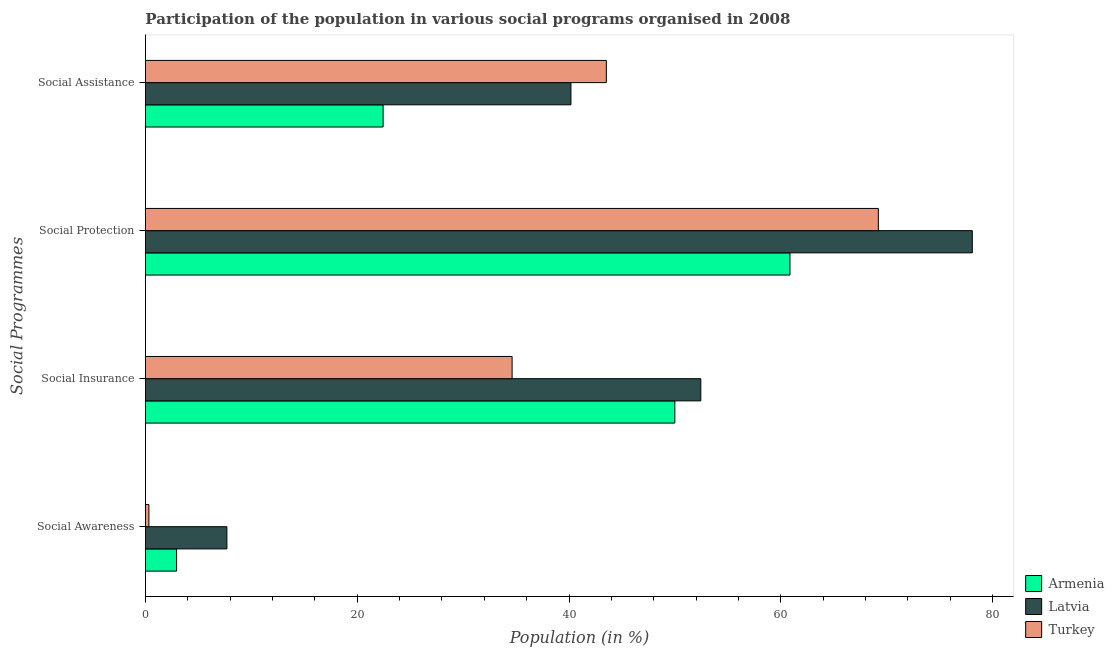How many different coloured bars are there?
Make the answer very short. 3. How many groups of bars are there?
Offer a very short reply. 4. Are the number of bars on each tick of the Y-axis equal?
Offer a terse response. Yes. How many bars are there on the 4th tick from the bottom?
Your answer should be very brief. 3. What is the label of the 4th group of bars from the top?
Provide a succinct answer. Social Awareness. What is the participation of population in social assistance programs in Armenia?
Make the answer very short. 22.44. Across all countries, what is the maximum participation of population in social assistance programs?
Provide a succinct answer. 43.52. Across all countries, what is the minimum participation of population in social assistance programs?
Keep it short and to the point. 22.44. In which country was the participation of population in social insurance programs maximum?
Your answer should be compact. Latvia. In which country was the participation of population in social assistance programs minimum?
Make the answer very short. Armenia. What is the total participation of population in social assistance programs in the graph?
Your answer should be very brief. 106.15. What is the difference between the participation of population in social insurance programs in Latvia and that in Turkey?
Ensure brevity in your answer.  17.82. What is the difference between the participation of population in social assistance programs in Armenia and the participation of population in social awareness programs in Turkey?
Provide a succinct answer. 22.12. What is the average participation of population in social insurance programs per country?
Keep it short and to the point. 45.69. What is the difference between the participation of population in social protection programs and participation of population in social assistance programs in Turkey?
Your answer should be very brief. 25.68. In how many countries, is the participation of population in social insurance programs greater than 48 %?
Your answer should be compact. 2. What is the ratio of the participation of population in social assistance programs in Latvia to that in Turkey?
Your answer should be compact. 0.92. Is the difference between the participation of population in social protection programs in Armenia and Latvia greater than the difference between the participation of population in social awareness programs in Armenia and Latvia?
Make the answer very short. No. What is the difference between the highest and the second highest participation of population in social insurance programs?
Give a very brief answer. 2.45. What is the difference between the highest and the lowest participation of population in social insurance programs?
Provide a succinct answer. 17.82. In how many countries, is the participation of population in social assistance programs greater than the average participation of population in social assistance programs taken over all countries?
Your answer should be compact. 2. Is the sum of the participation of population in social awareness programs in Armenia and Latvia greater than the maximum participation of population in social assistance programs across all countries?
Provide a succinct answer. No. Is it the case that in every country, the sum of the participation of population in social assistance programs and participation of population in social awareness programs is greater than the sum of participation of population in social insurance programs and participation of population in social protection programs?
Your answer should be compact. Yes. How many bars are there?
Offer a very short reply. 12. Are all the bars in the graph horizontal?
Give a very brief answer. Yes. How many countries are there in the graph?
Offer a terse response. 3. Are the values on the major ticks of X-axis written in scientific E-notation?
Your response must be concise. No. Does the graph contain any zero values?
Your answer should be compact. No. Where does the legend appear in the graph?
Give a very brief answer. Bottom right. How are the legend labels stacked?
Offer a very short reply. Vertical. What is the title of the graph?
Make the answer very short. Participation of the population in various social programs organised in 2008. What is the label or title of the Y-axis?
Give a very brief answer. Social Programmes. What is the Population (in %) in Armenia in Social Awareness?
Provide a short and direct response. 2.94. What is the Population (in %) in Latvia in Social Awareness?
Offer a very short reply. 7.69. What is the Population (in %) of Turkey in Social Awareness?
Offer a very short reply. 0.33. What is the Population (in %) of Armenia in Social Insurance?
Provide a short and direct response. 49.99. What is the Population (in %) in Latvia in Social Insurance?
Keep it short and to the point. 52.44. What is the Population (in %) of Turkey in Social Insurance?
Make the answer very short. 34.62. What is the Population (in %) in Armenia in Social Protection?
Your response must be concise. 60.86. What is the Population (in %) of Latvia in Social Protection?
Your answer should be compact. 78.08. What is the Population (in %) of Turkey in Social Protection?
Your answer should be very brief. 69.21. What is the Population (in %) in Armenia in Social Assistance?
Your answer should be very brief. 22.44. What is the Population (in %) in Latvia in Social Assistance?
Offer a very short reply. 40.18. What is the Population (in %) in Turkey in Social Assistance?
Provide a short and direct response. 43.52. Across all Social Programmes, what is the maximum Population (in %) in Armenia?
Ensure brevity in your answer.  60.86. Across all Social Programmes, what is the maximum Population (in %) of Latvia?
Give a very brief answer. 78.08. Across all Social Programmes, what is the maximum Population (in %) in Turkey?
Provide a short and direct response. 69.21. Across all Social Programmes, what is the minimum Population (in %) in Armenia?
Keep it short and to the point. 2.94. Across all Social Programmes, what is the minimum Population (in %) of Latvia?
Your answer should be compact. 7.69. Across all Social Programmes, what is the minimum Population (in %) of Turkey?
Ensure brevity in your answer.  0.33. What is the total Population (in %) of Armenia in the graph?
Your answer should be compact. 136.24. What is the total Population (in %) of Latvia in the graph?
Ensure brevity in your answer.  178.4. What is the total Population (in %) in Turkey in the graph?
Provide a short and direct response. 147.68. What is the difference between the Population (in %) in Armenia in Social Awareness and that in Social Insurance?
Offer a terse response. -47.05. What is the difference between the Population (in %) of Latvia in Social Awareness and that in Social Insurance?
Make the answer very short. -44.75. What is the difference between the Population (in %) of Turkey in Social Awareness and that in Social Insurance?
Make the answer very short. -34.3. What is the difference between the Population (in %) in Armenia in Social Awareness and that in Social Protection?
Ensure brevity in your answer.  -57.92. What is the difference between the Population (in %) of Latvia in Social Awareness and that in Social Protection?
Offer a terse response. -70.39. What is the difference between the Population (in %) of Turkey in Social Awareness and that in Social Protection?
Your answer should be compact. -68.88. What is the difference between the Population (in %) in Armenia in Social Awareness and that in Social Assistance?
Your answer should be compact. -19.5. What is the difference between the Population (in %) in Latvia in Social Awareness and that in Social Assistance?
Your answer should be very brief. -32.49. What is the difference between the Population (in %) of Turkey in Social Awareness and that in Social Assistance?
Keep it short and to the point. -43.2. What is the difference between the Population (in %) of Armenia in Social Insurance and that in Social Protection?
Keep it short and to the point. -10.87. What is the difference between the Population (in %) in Latvia in Social Insurance and that in Social Protection?
Keep it short and to the point. -25.64. What is the difference between the Population (in %) of Turkey in Social Insurance and that in Social Protection?
Provide a short and direct response. -34.58. What is the difference between the Population (in %) in Armenia in Social Insurance and that in Social Assistance?
Provide a succinct answer. 27.55. What is the difference between the Population (in %) in Latvia in Social Insurance and that in Social Assistance?
Provide a succinct answer. 12.26. What is the difference between the Population (in %) in Turkey in Social Insurance and that in Social Assistance?
Your answer should be very brief. -8.9. What is the difference between the Population (in %) of Armenia in Social Protection and that in Social Assistance?
Your answer should be very brief. 38.42. What is the difference between the Population (in %) of Latvia in Social Protection and that in Social Assistance?
Offer a terse response. 37.9. What is the difference between the Population (in %) in Turkey in Social Protection and that in Social Assistance?
Give a very brief answer. 25.68. What is the difference between the Population (in %) in Armenia in Social Awareness and the Population (in %) in Latvia in Social Insurance?
Provide a short and direct response. -49.5. What is the difference between the Population (in %) in Armenia in Social Awareness and the Population (in %) in Turkey in Social Insurance?
Provide a succinct answer. -31.68. What is the difference between the Population (in %) in Latvia in Social Awareness and the Population (in %) in Turkey in Social Insurance?
Provide a succinct answer. -26.93. What is the difference between the Population (in %) of Armenia in Social Awareness and the Population (in %) of Latvia in Social Protection?
Provide a succinct answer. -75.14. What is the difference between the Population (in %) of Armenia in Social Awareness and the Population (in %) of Turkey in Social Protection?
Provide a short and direct response. -66.27. What is the difference between the Population (in %) of Latvia in Social Awareness and the Population (in %) of Turkey in Social Protection?
Your answer should be compact. -61.52. What is the difference between the Population (in %) of Armenia in Social Awareness and the Population (in %) of Latvia in Social Assistance?
Your answer should be very brief. -37.24. What is the difference between the Population (in %) of Armenia in Social Awareness and the Population (in %) of Turkey in Social Assistance?
Provide a succinct answer. -40.58. What is the difference between the Population (in %) of Latvia in Social Awareness and the Population (in %) of Turkey in Social Assistance?
Give a very brief answer. -35.83. What is the difference between the Population (in %) in Armenia in Social Insurance and the Population (in %) in Latvia in Social Protection?
Keep it short and to the point. -28.09. What is the difference between the Population (in %) in Armenia in Social Insurance and the Population (in %) in Turkey in Social Protection?
Make the answer very short. -19.22. What is the difference between the Population (in %) in Latvia in Social Insurance and the Population (in %) in Turkey in Social Protection?
Keep it short and to the point. -16.76. What is the difference between the Population (in %) of Armenia in Social Insurance and the Population (in %) of Latvia in Social Assistance?
Your answer should be compact. 9.81. What is the difference between the Population (in %) of Armenia in Social Insurance and the Population (in %) of Turkey in Social Assistance?
Provide a succinct answer. 6.47. What is the difference between the Population (in %) in Latvia in Social Insurance and the Population (in %) in Turkey in Social Assistance?
Make the answer very short. 8.92. What is the difference between the Population (in %) of Armenia in Social Protection and the Population (in %) of Latvia in Social Assistance?
Provide a succinct answer. 20.68. What is the difference between the Population (in %) of Armenia in Social Protection and the Population (in %) of Turkey in Social Assistance?
Provide a short and direct response. 17.34. What is the difference between the Population (in %) in Latvia in Social Protection and the Population (in %) in Turkey in Social Assistance?
Your answer should be very brief. 34.56. What is the average Population (in %) of Armenia per Social Programmes?
Provide a short and direct response. 34.06. What is the average Population (in %) of Latvia per Social Programmes?
Your response must be concise. 44.6. What is the average Population (in %) in Turkey per Social Programmes?
Your answer should be very brief. 36.92. What is the difference between the Population (in %) in Armenia and Population (in %) in Latvia in Social Awareness?
Offer a terse response. -4.75. What is the difference between the Population (in %) of Armenia and Population (in %) of Turkey in Social Awareness?
Ensure brevity in your answer.  2.61. What is the difference between the Population (in %) in Latvia and Population (in %) in Turkey in Social Awareness?
Ensure brevity in your answer.  7.37. What is the difference between the Population (in %) in Armenia and Population (in %) in Latvia in Social Insurance?
Your answer should be compact. -2.45. What is the difference between the Population (in %) in Armenia and Population (in %) in Turkey in Social Insurance?
Make the answer very short. 15.37. What is the difference between the Population (in %) of Latvia and Population (in %) of Turkey in Social Insurance?
Offer a terse response. 17.82. What is the difference between the Population (in %) of Armenia and Population (in %) of Latvia in Social Protection?
Provide a short and direct response. -17.22. What is the difference between the Population (in %) in Armenia and Population (in %) in Turkey in Social Protection?
Provide a succinct answer. -8.34. What is the difference between the Population (in %) of Latvia and Population (in %) of Turkey in Social Protection?
Make the answer very short. 8.87. What is the difference between the Population (in %) of Armenia and Population (in %) of Latvia in Social Assistance?
Provide a succinct answer. -17.74. What is the difference between the Population (in %) of Armenia and Population (in %) of Turkey in Social Assistance?
Your response must be concise. -21.08. What is the difference between the Population (in %) in Latvia and Population (in %) in Turkey in Social Assistance?
Ensure brevity in your answer.  -3.34. What is the ratio of the Population (in %) in Armenia in Social Awareness to that in Social Insurance?
Offer a very short reply. 0.06. What is the ratio of the Population (in %) of Latvia in Social Awareness to that in Social Insurance?
Provide a short and direct response. 0.15. What is the ratio of the Population (in %) in Turkey in Social Awareness to that in Social Insurance?
Keep it short and to the point. 0.01. What is the ratio of the Population (in %) of Armenia in Social Awareness to that in Social Protection?
Ensure brevity in your answer.  0.05. What is the ratio of the Population (in %) in Latvia in Social Awareness to that in Social Protection?
Give a very brief answer. 0.1. What is the ratio of the Population (in %) in Turkey in Social Awareness to that in Social Protection?
Offer a terse response. 0. What is the ratio of the Population (in %) in Armenia in Social Awareness to that in Social Assistance?
Provide a short and direct response. 0.13. What is the ratio of the Population (in %) of Latvia in Social Awareness to that in Social Assistance?
Keep it short and to the point. 0.19. What is the ratio of the Population (in %) of Turkey in Social Awareness to that in Social Assistance?
Give a very brief answer. 0.01. What is the ratio of the Population (in %) in Armenia in Social Insurance to that in Social Protection?
Ensure brevity in your answer.  0.82. What is the ratio of the Population (in %) in Latvia in Social Insurance to that in Social Protection?
Offer a very short reply. 0.67. What is the ratio of the Population (in %) of Turkey in Social Insurance to that in Social Protection?
Offer a very short reply. 0.5. What is the ratio of the Population (in %) of Armenia in Social Insurance to that in Social Assistance?
Keep it short and to the point. 2.23. What is the ratio of the Population (in %) of Latvia in Social Insurance to that in Social Assistance?
Ensure brevity in your answer.  1.31. What is the ratio of the Population (in %) of Turkey in Social Insurance to that in Social Assistance?
Offer a very short reply. 0.8. What is the ratio of the Population (in %) of Armenia in Social Protection to that in Social Assistance?
Your answer should be very brief. 2.71. What is the ratio of the Population (in %) of Latvia in Social Protection to that in Social Assistance?
Offer a terse response. 1.94. What is the ratio of the Population (in %) of Turkey in Social Protection to that in Social Assistance?
Offer a terse response. 1.59. What is the difference between the highest and the second highest Population (in %) in Armenia?
Offer a terse response. 10.87. What is the difference between the highest and the second highest Population (in %) in Latvia?
Give a very brief answer. 25.64. What is the difference between the highest and the second highest Population (in %) in Turkey?
Give a very brief answer. 25.68. What is the difference between the highest and the lowest Population (in %) of Armenia?
Ensure brevity in your answer.  57.92. What is the difference between the highest and the lowest Population (in %) in Latvia?
Your response must be concise. 70.39. What is the difference between the highest and the lowest Population (in %) in Turkey?
Your answer should be compact. 68.88. 